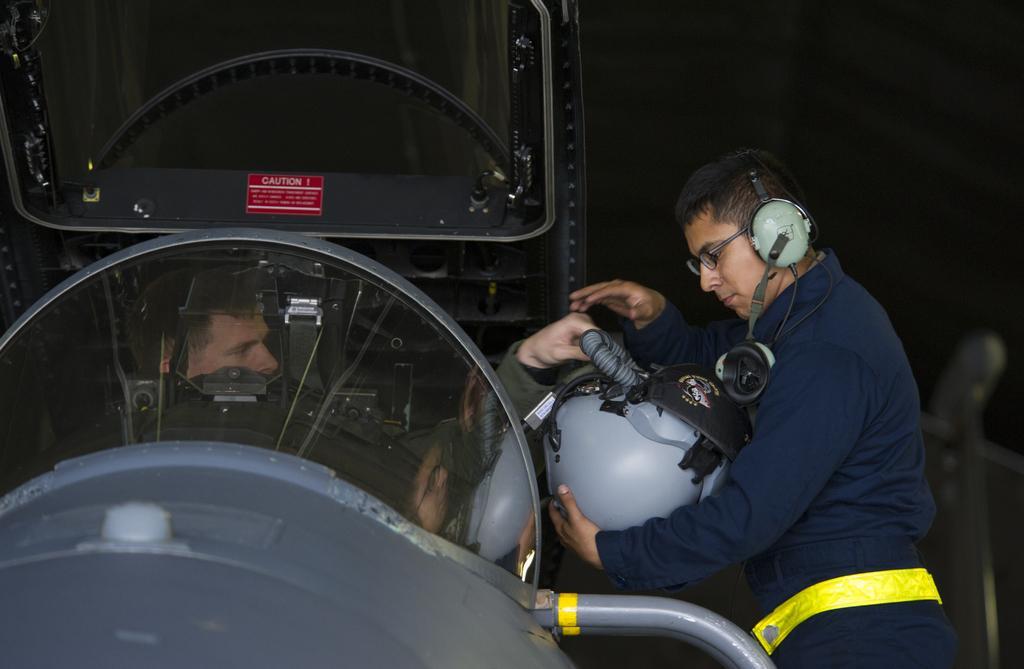Can you describe this image briefly? In this image there is a person sitting in the vehicle. Beside the vehicle there is a person. He is holding a helmet. He is wearing headphones and spectacles. 